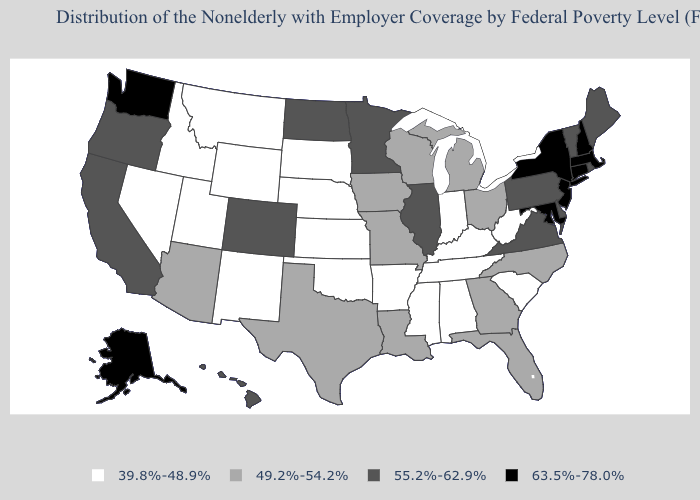Name the states that have a value in the range 63.5%-78.0%?
Keep it brief. Alaska, Connecticut, Maryland, Massachusetts, New Hampshire, New Jersey, New York, Washington. Name the states that have a value in the range 55.2%-62.9%?
Keep it brief. California, Colorado, Delaware, Hawaii, Illinois, Maine, Minnesota, North Dakota, Oregon, Pennsylvania, Rhode Island, Vermont, Virginia. Which states have the lowest value in the MidWest?
Give a very brief answer. Indiana, Kansas, Nebraska, South Dakota. Name the states that have a value in the range 39.8%-48.9%?
Concise answer only. Alabama, Arkansas, Idaho, Indiana, Kansas, Kentucky, Mississippi, Montana, Nebraska, Nevada, New Mexico, Oklahoma, South Carolina, South Dakota, Tennessee, Utah, West Virginia, Wyoming. Which states hav the highest value in the Northeast?
Answer briefly. Connecticut, Massachusetts, New Hampshire, New Jersey, New York. What is the value of Alabama?
Short answer required. 39.8%-48.9%. Does the first symbol in the legend represent the smallest category?
Be succinct. Yes. What is the value of Rhode Island?
Be succinct. 55.2%-62.9%. What is the value of Texas?
Quick response, please. 49.2%-54.2%. Among the states that border Idaho , does Washington have the highest value?
Short answer required. Yes. What is the highest value in states that border California?
Be succinct. 55.2%-62.9%. Name the states that have a value in the range 55.2%-62.9%?
Give a very brief answer. California, Colorado, Delaware, Hawaii, Illinois, Maine, Minnesota, North Dakota, Oregon, Pennsylvania, Rhode Island, Vermont, Virginia. Name the states that have a value in the range 49.2%-54.2%?
Keep it brief. Arizona, Florida, Georgia, Iowa, Louisiana, Michigan, Missouri, North Carolina, Ohio, Texas, Wisconsin. Name the states that have a value in the range 39.8%-48.9%?
Quick response, please. Alabama, Arkansas, Idaho, Indiana, Kansas, Kentucky, Mississippi, Montana, Nebraska, Nevada, New Mexico, Oklahoma, South Carolina, South Dakota, Tennessee, Utah, West Virginia, Wyoming. How many symbols are there in the legend?
Keep it brief. 4. 